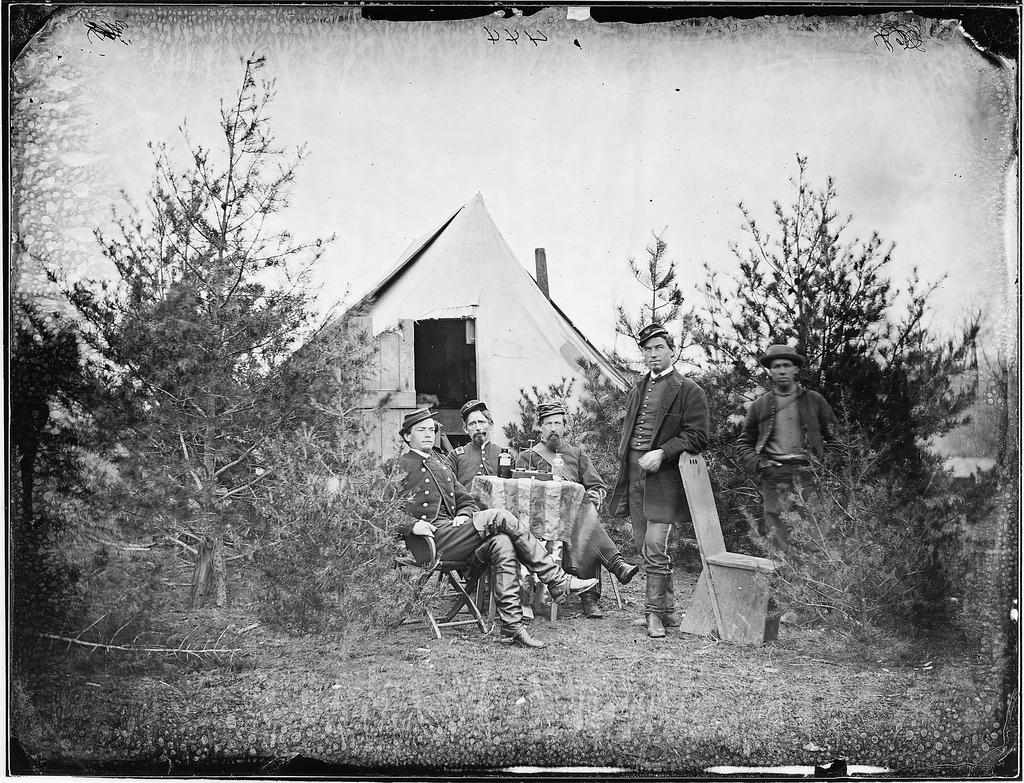In one or two sentences, can you explain what this image depicts? Here we can see a picture in which we can see a group of people sitting and standing, behind them we can see a hut and trees present 